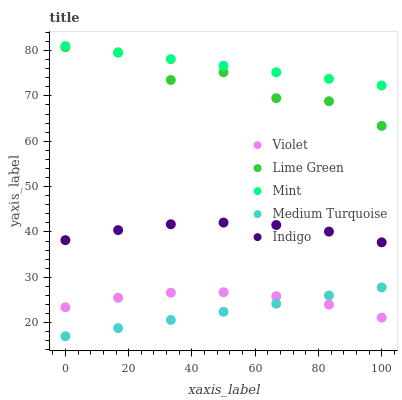Does Medium Turquoise have the minimum area under the curve?
Answer yes or no. Yes. Does Mint have the maximum area under the curve?
Answer yes or no. Yes. Does Lime Green have the minimum area under the curve?
Answer yes or no. No. Does Lime Green have the maximum area under the curve?
Answer yes or no. No. Is Medium Turquoise the smoothest?
Answer yes or no. Yes. Is Lime Green the roughest?
Answer yes or no. Yes. Is Mint the smoothest?
Answer yes or no. No. Is Mint the roughest?
Answer yes or no. No. Does Medium Turquoise have the lowest value?
Answer yes or no. Yes. Does Lime Green have the lowest value?
Answer yes or no. No. Does Mint have the highest value?
Answer yes or no. Yes. Does Lime Green have the highest value?
Answer yes or no. No. Is Medium Turquoise less than Mint?
Answer yes or no. Yes. Is Lime Green greater than Medium Turquoise?
Answer yes or no. Yes. Does Lime Green intersect Mint?
Answer yes or no. Yes. Is Lime Green less than Mint?
Answer yes or no. No. Is Lime Green greater than Mint?
Answer yes or no. No. Does Medium Turquoise intersect Mint?
Answer yes or no. No. 